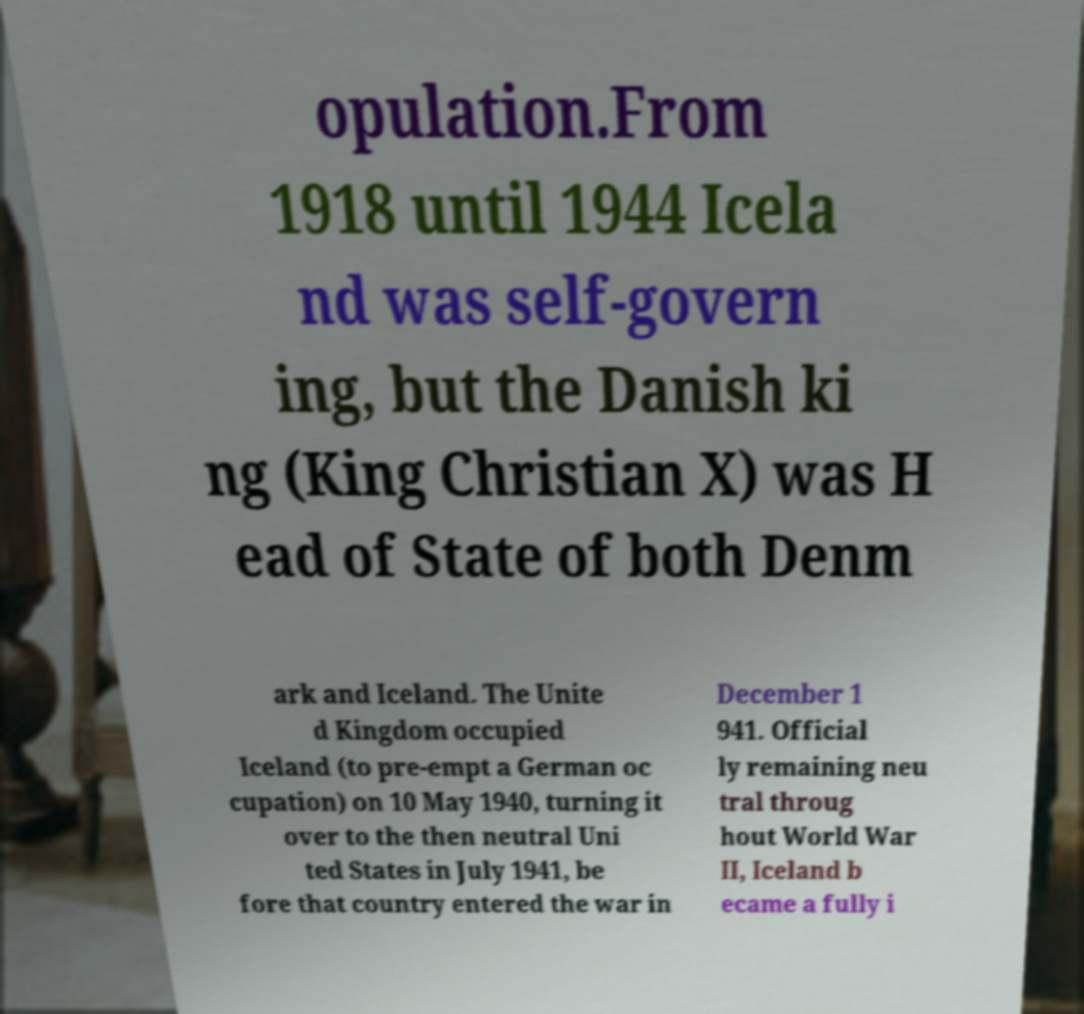Can you accurately transcribe the text from the provided image for me? opulation.From 1918 until 1944 Icela nd was self-govern ing, but the Danish ki ng (King Christian X) was H ead of State of both Denm ark and Iceland. The Unite d Kingdom occupied Iceland (to pre-empt a German oc cupation) on 10 May 1940, turning it over to the then neutral Uni ted States in July 1941, be fore that country entered the war in December 1 941. Official ly remaining neu tral throug hout World War II, Iceland b ecame a fully i 